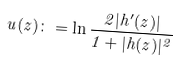Convert formula to latex. <formula><loc_0><loc_0><loc_500><loc_500>u ( z ) \colon = \ln \frac { 2 | h ^ { \prime } ( z ) | } { 1 + | h ( z ) | ^ { 2 } }</formula> 